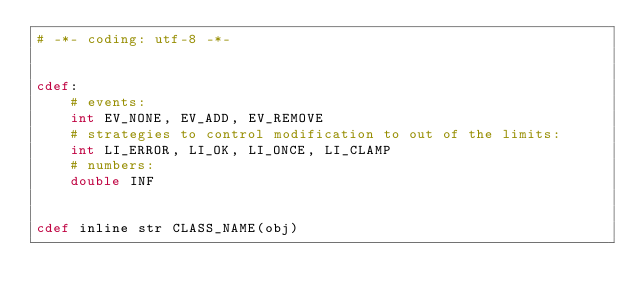Convert code to text. <code><loc_0><loc_0><loc_500><loc_500><_Cython_># -*- coding: utf-8 -*-


cdef:
    # events:
    int EV_NONE, EV_ADD, EV_REMOVE
    # strategies to control modification to out of the limits:
    int LI_ERROR, LI_OK, LI_ONCE, LI_CLAMP
    # numbers:
    double INF


cdef inline str CLASS_NAME(obj)
</code> 